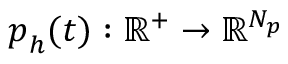<formula> <loc_0><loc_0><loc_500><loc_500>p _ { h } ( t ) \colon \mathbb { R } ^ { + } \rightarrow \mathbb { R } ^ { N _ { p } }</formula> 